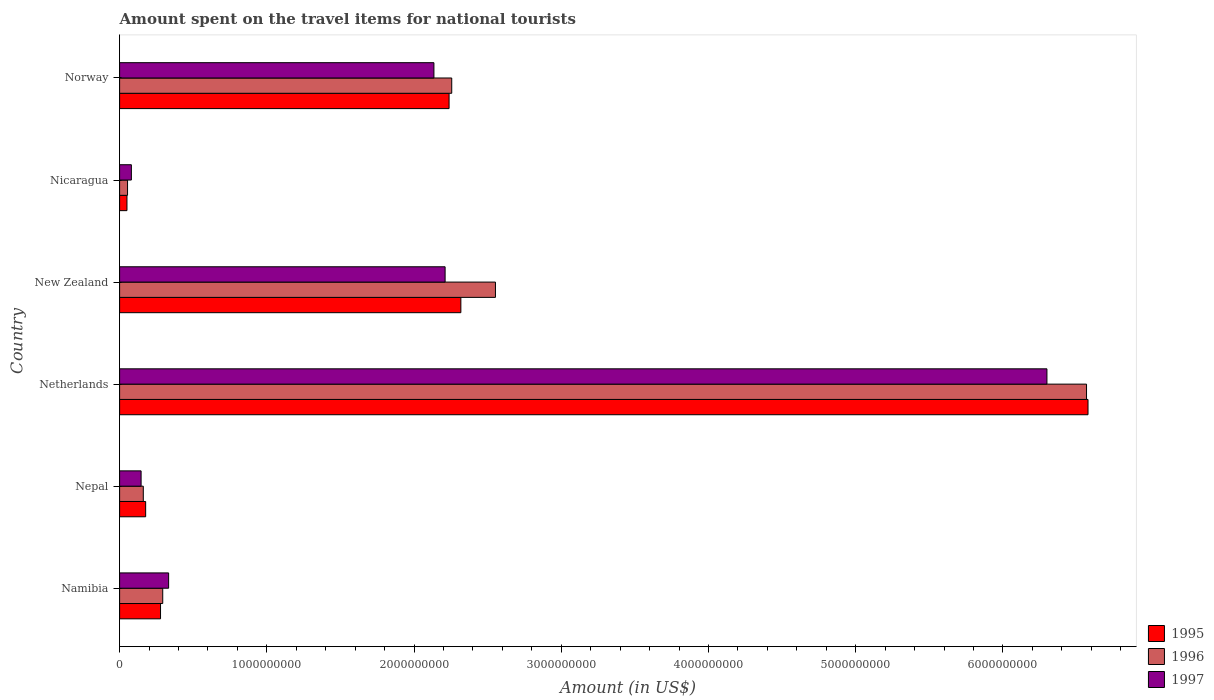How many different coloured bars are there?
Your answer should be very brief. 3. How many groups of bars are there?
Make the answer very short. 6. Are the number of bars per tick equal to the number of legend labels?
Your answer should be very brief. Yes. Are the number of bars on each tick of the Y-axis equal?
Make the answer very short. Yes. How many bars are there on the 1st tick from the top?
Ensure brevity in your answer.  3. How many bars are there on the 6th tick from the bottom?
Your answer should be very brief. 3. In how many cases, is the number of bars for a given country not equal to the number of legend labels?
Give a very brief answer. 0. What is the amount spent on the travel items for national tourists in 1996 in Nicaragua?
Keep it short and to the point. 5.40e+07. Across all countries, what is the maximum amount spent on the travel items for national tourists in 1997?
Provide a succinct answer. 6.30e+09. Across all countries, what is the minimum amount spent on the travel items for national tourists in 1995?
Provide a short and direct response. 5.00e+07. In which country was the amount spent on the travel items for national tourists in 1995 minimum?
Provide a succinct answer. Nicaragua. What is the total amount spent on the travel items for national tourists in 1997 in the graph?
Provide a succinct answer. 1.12e+1. What is the difference between the amount spent on the travel items for national tourists in 1995 in Nepal and that in Netherlands?
Your answer should be very brief. -6.40e+09. What is the difference between the amount spent on the travel items for national tourists in 1996 in New Zealand and the amount spent on the travel items for national tourists in 1997 in Norway?
Your answer should be compact. 4.18e+08. What is the average amount spent on the travel items for national tourists in 1997 per country?
Keep it short and to the point. 1.87e+09. What is the difference between the amount spent on the travel items for national tourists in 1997 and amount spent on the travel items for national tourists in 1995 in Netherlands?
Provide a short and direct response. -2.79e+08. What is the ratio of the amount spent on the travel items for national tourists in 1995 in Nepal to that in Nicaragua?
Provide a succinct answer. 3.54. What is the difference between the highest and the second highest amount spent on the travel items for national tourists in 1996?
Offer a very short reply. 4.02e+09. What is the difference between the highest and the lowest amount spent on the travel items for national tourists in 1996?
Your answer should be very brief. 6.51e+09. In how many countries, is the amount spent on the travel items for national tourists in 1997 greater than the average amount spent on the travel items for national tourists in 1997 taken over all countries?
Your answer should be compact. 3. Are all the bars in the graph horizontal?
Your response must be concise. Yes. Are the values on the major ticks of X-axis written in scientific E-notation?
Offer a very short reply. No. Does the graph contain grids?
Make the answer very short. No. How many legend labels are there?
Keep it short and to the point. 3. How are the legend labels stacked?
Ensure brevity in your answer.  Vertical. What is the title of the graph?
Offer a terse response. Amount spent on the travel items for national tourists. Does "1975" appear as one of the legend labels in the graph?
Your answer should be compact. No. What is the label or title of the X-axis?
Provide a succinct answer. Amount (in US$). What is the label or title of the Y-axis?
Offer a terse response. Country. What is the Amount (in US$) in 1995 in Namibia?
Provide a short and direct response. 2.78e+08. What is the Amount (in US$) of 1996 in Namibia?
Provide a short and direct response. 2.93e+08. What is the Amount (in US$) in 1997 in Namibia?
Offer a terse response. 3.33e+08. What is the Amount (in US$) in 1995 in Nepal?
Ensure brevity in your answer.  1.77e+08. What is the Amount (in US$) in 1996 in Nepal?
Ensure brevity in your answer.  1.61e+08. What is the Amount (in US$) in 1997 in Nepal?
Offer a very short reply. 1.46e+08. What is the Amount (in US$) of 1995 in Netherlands?
Make the answer very short. 6.58e+09. What is the Amount (in US$) of 1996 in Netherlands?
Provide a short and direct response. 6.57e+09. What is the Amount (in US$) of 1997 in Netherlands?
Give a very brief answer. 6.30e+09. What is the Amount (in US$) of 1995 in New Zealand?
Ensure brevity in your answer.  2.32e+09. What is the Amount (in US$) of 1996 in New Zealand?
Offer a terse response. 2.55e+09. What is the Amount (in US$) of 1997 in New Zealand?
Ensure brevity in your answer.  2.21e+09. What is the Amount (in US$) of 1995 in Nicaragua?
Offer a very short reply. 5.00e+07. What is the Amount (in US$) of 1996 in Nicaragua?
Provide a short and direct response. 5.40e+07. What is the Amount (in US$) in 1997 in Nicaragua?
Your response must be concise. 8.00e+07. What is the Amount (in US$) in 1995 in Norway?
Provide a succinct answer. 2.24e+09. What is the Amount (in US$) of 1996 in Norway?
Your answer should be compact. 2.26e+09. What is the Amount (in US$) in 1997 in Norway?
Offer a terse response. 2.14e+09. Across all countries, what is the maximum Amount (in US$) of 1995?
Provide a succinct answer. 6.58e+09. Across all countries, what is the maximum Amount (in US$) of 1996?
Provide a short and direct response. 6.57e+09. Across all countries, what is the maximum Amount (in US$) in 1997?
Offer a terse response. 6.30e+09. Across all countries, what is the minimum Amount (in US$) of 1995?
Your answer should be very brief. 5.00e+07. Across all countries, what is the minimum Amount (in US$) in 1996?
Offer a very short reply. 5.40e+07. Across all countries, what is the minimum Amount (in US$) in 1997?
Provide a short and direct response. 8.00e+07. What is the total Amount (in US$) in 1995 in the graph?
Ensure brevity in your answer.  1.16e+1. What is the total Amount (in US$) of 1996 in the graph?
Offer a very short reply. 1.19e+1. What is the total Amount (in US$) of 1997 in the graph?
Provide a succinct answer. 1.12e+1. What is the difference between the Amount (in US$) in 1995 in Namibia and that in Nepal?
Your response must be concise. 1.01e+08. What is the difference between the Amount (in US$) in 1996 in Namibia and that in Nepal?
Make the answer very short. 1.32e+08. What is the difference between the Amount (in US$) in 1997 in Namibia and that in Nepal?
Your answer should be very brief. 1.87e+08. What is the difference between the Amount (in US$) in 1995 in Namibia and that in Netherlands?
Provide a short and direct response. -6.30e+09. What is the difference between the Amount (in US$) of 1996 in Namibia and that in Netherlands?
Keep it short and to the point. -6.28e+09. What is the difference between the Amount (in US$) of 1997 in Namibia and that in Netherlands?
Your response must be concise. -5.97e+09. What is the difference between the Amount (in US$) in 1995 in Namibia and that in New Zealand?
Keep it short and to the point. -2.04e+09. What is the difference between the Amount (in US$) in 1996 in Namibia and that in New Zealand?
Give a very brief answer. -2.26e+09. What is the difference between the Amount (in US$) of 1997 in Namibia and that in New Zealand?
Give a very brief answer. -1.88e+09. What is the difference between the Amount (in US$) of 1995 in Namibia and that in Nicaragua?
Offer a terse response. 2.28e+08. What is the difference between the Amount (in US$) of 1996 in Namibia and that in Nicaragua?
Your answer should be very brief. 2.39e+08. What is the difference between the Amount (in US$) of 1997 in Namibia and that in Nicaragua?
Offer a very short reply. 2.53e+08. What is the difference between the Amount (in US$) of 1995 in Namibia and that in Norway?
Your answer should be very brief. -1.96e+09. What is the difference between the Amount (in US$) in 1996 in Namibia and that in Norway?
Provide a short and direct response. -1.96e+09. What is the difference between the Amount (in US$) in 1997 in Namibia and that in Norway?
Your answer should be very brief. -1.80e+09. What is the difference between the Amount (in US$) of 1995 in Nepal and that in Netherlands?
Ensure brevity in your answer.  -6.40e+09. What is the difference between the Amount (in US$) of 1996 in Nepal and that in Netherlands?
Your answer should be very brief. -6.41e+09. What is the difference between the Amount (in US$) in 1997 in Nepal and that in Netherlands?
Give a very brief answer. -6.15e+09. What is the difference between the Amount (in US$) of 1995 in Nepal and that in New Zealand?
Ensure brevity in your answer.  -2.14e+09. What is the difference between the Amount (in US$) of 1996 in Nepal and that in New Zealand?
Your response must be concise. -2.39e+09. What is the difference between the Amount (in US$) in 1997 in Nepal and that in New Zealand?
Provide a succinct answer. -2.06e+09. What is the difference between the Amount (in US$) of 1995 in Nepal and that in Nicaragua?
Offer a terse response. 1.27e+08. What is the difference between the Amount (in US$) in 1996 in Nepal and that in Nicaragua?
Offer a very short reply. 1.07e+08. What is the difference between the Amount (in US$) of 1997 in Nepal and that in Nicaragua?
Your answer should be very brief. 6.60e+07. What is the difference between the Amount (in US$) of 1995 in Nepal and that in Norway?
Your answer should be very brief. -2.06e+09. What is the difference between the Amount (in US$) in 1996 in Nepal and that in Norway?
Your answer should be very brief. -2.10e+09. What is the difference between the Amount (in US$) in 1997 in Nepal and that in Norway?
Your answer should be compact. -1.99e+09. What is the difference between the Amount (in US$) in 1995 in Netherlands and that in New Zealand?
Keep it short and to the point. 4.26e+09. What is the difference between the Amount (in US$) of 1996 in Netherlands and that in New Zealand?
Offer a terse response. 4.02e+09. What is the difference between the Amount (in US$) in 1997 in Netherlands and that in New Zealand?
Keep it short and to the point. 4.09e+09. What is the difference between the Amount (in US$) in 1995 in Netherlands and that in Nicaragua?
Offer a terse response. 6.53e+09. What is the difference between the Amount (in US$) in 1996 in Netherlands and that in Nicaragua?
Make the answer very short. 6.51e+09. What is the difference between the Amount (in US$) of 1997 in Netherlands and that in Nicaragua?
Your answer should be very brief. 6.22e+09. What is the difference between the Amount (in US$) of 1995 in Netherlands and that in Norway?
Make the answer very short. 4.34e+09. What is the difference between the Amount (in US$) of 1996 in Netherlands and that in Norway?
Make the answer very short. 4.31e+09. What is the difference between the Amount (in US$) of 1997 in Netherlands and that in Norway?
Make the answer very short. 4.16e+09. What is the difference between the Amount (in US$) of 1995 in New Zealand and that in Nicaragua?
Your answer should be compact. 2.27e+09. What is the difference between the Amount (in US$) in 1996 in New Zealand and that in Nicaragua?
Give a very brief answer. 2.50e+09. What is the difference between the Amount (in US$) in 1997 in New Zealand and that in Nicaragua?
Give a very brief answer. 2.13e+09. What is the difference between the Amount (in US$) in 1995 in New Zealand and that in Norway?
Your response must be concise. 8.00e+07. What is the difference between the Amount (in US$) in 1996 in New Zealand and that in Norway?
Your answer should be compact. 2.97e+08. What is the difference between the Amount (in US$) in 1997 in New Zealand and that in Norway?
Keep it short and to the point. 7.60e+07. What is the difference between the Amount (in US$) of 1995 in Nicaragua and that in Norway?
Keep it short and to the point. -2.19e+09. What is the difference between the Amount (in US$) of 1996 in Nicaragua and that in Norway?
Offer a terse response. -2.20e+09. What is the difference between the Amount (in US$) of 1997 in Nicaragua and that in Norway?
Your answer should be very brief. -2.06e+09. What is the difference between the Amount (in US$) of 1995 in Namibia and the Amount (in US$) of 1996 in Nepal?
Your response must be concise. 1.17e+08. What is the difference between the Amount (in US$) of 1995 in Namibia and the Amount (in US$) of 1997 in Nepal?
Offer a very short reply. 1.32e+08. What is the difference between the Amount (in US$) in 1996 in Namibia and the Amount (in US$) in 1997 in Nepal?
Keep it short and to the point. 1.47e+08. What is the difference between the Amount (in US$) in 1995 in Namibia and the Amount (in US$) in 1996 in Netherlands?
Your answer should be compact. -6.29e+09. What is the difference between the Amount (in US$) in 1995 in Namibia and the Amount (in US$) in 1997 in Netherlands?
Your answer should be very brief. -6.02e+09. What is the difference between the Amount (in US$) in 1996 in Namibia and the Amount (in US$) in 1997 in Netherlands?
Provide a short and direct response. -6.01e+09. What is the difference between the Amount (in US$) of 1995 in Namibia and the Amount (in US$) of 1996 in New Zealand?
Your response must be concise. -2.28e+09. What is the difference between the Amount (in US$) of 1995 in Namibia and the Amount (in US$) of 1997 in New Zealand?
Your answer should be compact. -1.93e+09. What is the difference between the Amount (in US$) in 1996 in Namibia and the Amount (in US$) in 1997 in New Zealand?
Your answer should be compact. -1.92e+09. What is the difference between the Amount (in US$) in 1995 in Namibia and the Amount (in US$) in 1996 in Nicaragua?
Your answer should be compact. 2.24e+08. What is the difference between the Amount (in US$) of 1995 in Namibia and the Amount (in US$) of 1997 in Nicaragua?
Provide a succinct answer. 1.98e+08. What is the difference between the Amount (in US$) in 1996 in Namibia and the Amount (in US$) in 1997 in Nicaragua?
Your response must be concise. 2.13e+08. What is the difference between the Amount (in US$) in 1995 in Namibia and the Amount (in US$) in 1996 in Norway?
Give a very brief answer. -1.98e+09. What is the difference between the Amount (in US$) of 1995 in Namibia and the Amount (in US$) of 1997 in Norway?
Your answer should be compact. -1.86e+09. What is the difference between the Amount (in US$) in 1996 in Namibia and the Amount (in US$) in 1997 in Norway?
Your response must be concise. -1.84e+09. What is the difference between the Amount (in US$) in 1995 in Nepal and the Amount (in US$) in 1996 in Netherlands?
Ensure brevity in your answer.  -6.39e+09. What is the difference between the Amount (in US$) in 1995 in Nepal and the Amount (in US$) in 1997 in Netherlands?
Your answer should be very brief. -6.12e+09. What is the difference between the Amount (in US$) in 1996 in Nepal and the Amount (in US$) in 1997 in Netherlands?
Provide a short and direct response. -6.14e+09. What is the difference between the Amount (in US$) of 1995 in Nepal and the Amount (in US$) of 1996 in New Zealand?
Your answer should be compact. -2.38e+09. What is the difference between the Amount (in US$) in 1995 in Nepal and the Amount (in US$) in 1997 in New Zealand?
Give a very brief answer. -2.03e+09. What is the difference between the Amount (in US$) of 1996 in Nepal and the Amount (in US$) of 1997 in New Zealand?
Your response must be concise. -2.05e+09. What is the difference between the Amount (in US$) of 1995 in Nepal and the Amount (in US$) of 1996 in Nicaragua?
Offer a very short reply. 1.23e+08. What is the difference between the Amount (in US$) of 1995 in Nepal and the Amount (in US$) of 1997 in Nicaragua?
Offer a very short reply. 9.70e+07. What is the difference between the Amount (in US$) in 1996 in Nepal and the Amount (in US$) in 1997 in Nicaragua?
Make the answer very short. 8.10e+07. What is the difference between the Amount (in US$) in 1995 in Nepal and the Amount (in US$) in 1996 in Norway?
Your answer should be compact. -2.08e+09. What is the difference between the Amount (in US$) of 1995 in Nepal and the Amount (in US$) of 1997 in Norway?
Provide a succinct answer. -1.96e+09. What is the difference between the Amount (in US$) of 1996 in Nepal and the Amount (in US$) of 1997 in Norway?
Your response must be concise. -1.97e+09. What is the difference between the Amount (in US$) of 1995 in Netherlands and the Amount (in US$) of 1996 in New Zealand?
Your answer should be very brief. 4.02e+09. What is the difference between the Amount (in US$) of 1995 in Netherlands and the Amount (in US$) of 1997 in New Zealand?
Make the answer very short. 4.37e+09. What is the difference between the Amount (in US$) in 1996 in Netherlands and the Amount (in US$) in 1997 in New Zealand?
Make the answer very short. 4.36e+09. What is the difference between the Amount (in US$) in 1995 in Netherlands and the Amount (in US$) in 1996 in Nicaragua?
Provide a short and direct response. 6.52e+09. What is the difference between the Amount (in US$) in 1995 in Netherlands and the Amount (in US$) in 1997 in Nicaragua?
Keep it short and to the point. 6.50e+09. What is the difference between the Amount (in US$) of 1996 in Netherlands and the Amount (in US$) of 1997 in Nicaragua?
Give a very brief answer. 6.49e+09. What is the difference between the Amount (in US$) in 1995 in Netherlands and the Amount (in US$) in 1996 in Norway?
Provide a short and direct response. 4.32e+09. What is the difference between the Amount (in US$) in 1995 in Netherlands and the Amount (in US$) in 1997 in Norway?
Ensure brevity in your answer.  4.44e+09. What is the difference between the Amount (in US$) in 1996 in Netherlands and the Amount (in US$) in 1997 in Norway?
Offer a very short reply. 4.43e+09. What is the difference between the Amount (in US$) of 1995 in New Zealand and the Amount (in US$) of 1996 in Nicaragua?
Your response must be concise. 2.26e+09. What is the difference between the Amount (in US$) of 1995 in New Zealand and the Amount (in US$) of 1997 in Nicaragua?
Offer a terse response. 2.24e+09. What is the difference between the Amount (in US$) in 1996 in New Zealand and the Amount (in US$) in 1997 in Nicaragua?
Your answer should be very brief. 2.47e+09. What is the difference between the Amount (in US$) of 1995 in New Zealand and the Amount (in US$) of 1996 in Norway?
Ensure brevity in your answer.  6.20e+07. What is the difference between the Amount (in US$) of 1995 in New Zealand and the Amount (in US$) of 1997 in Norway?
Make the answer very short. 1.83e+08. What is the difference between the Amount (in US$) of 1996 in New Zealand and the Amount (in US$) of 1997 in Norway?
Your answer should be compact. 4.18e+08. What is the difference between the Amount (in US$) in 1995 in Nicaragua and the Amount (in US$) in 1996 in Norway?
Your answer should be compact. -2.21e+09. What is the difference between the Amount (in US$) of 1995 in Nicaragua and the Amount (in US$) of 1997 in Norway?
Provide a short and direct response. -2.08e+09. What is the difference between the Amount (in US$) of 1996 in Nicaragua and the Amount (in US$) of 1997 in Norway?
Provide a short and direct response. -2.08e+09. What is the average Amount (in US$) in 1995 per country?
Keep it short and to the point. 1.94e+09. What is the average Amount (in US$) in 1996 per country?
Your answer should be compact. 1.98e+09. What is the average Amount (in US$) of 1997 per country?
Provide a short and direct response. 1.87e+09. What is the difference between the Amount (in US$) of 1995 and Amount (in US$) of 1996 in Namibia?
Make the answer very short. -1.50e+07. What is the difference between the Amount (in US$) of 1995 and Amount (in US$) of 1997 in Namibia?
Your response must be concise. -5.50e+07. What is the difference between the Amount (in US$) of 1996 and Amount (in US$) of 1997 in Namibia?
Your answer should be very brief. -4.00e+07. What is the difference between the Amount (in US$) in 1995 and Amount (in US$) in 1996 in Nepal?
Offer a terse response. 1.60e+07. What is the difference between the Amount (in US$) in 1995 and Amount (in US$) in 1997 in Nepal?
Your response must be concise. 3.10e+07. What is the difference between the Amount (in US$) of 1996 and Amount (in US$) of 1997 in Nepal?
Your response must be concise. 1.50e+07. What is the difference between the Amount (in US$) of 1995 and Amount (in US$) of 1996 in Netherlands?
Your answer should be very brief. 1.00e+07. What is the difference between the Amount (in US$) in 1995 and Amount (in US$) in 1997 in Netherlands?
Your answer should be very brief. 2.79e+08. What is the difference between the Amount (in US$) of 1996 and Amount (in US$) of 1997 in Netherlands?
Offer a terse response. 2.69e+08. What is the difference between the Amount (in US$) of 1995 and Amount (in US$) of 1996 in New Zealand?
Provide a succinct answer. -2.35e+08. What is the difference between the Amount (in US$) of 1995 and Amount (in US$) of 1997 in New Zealand?
Provide a succinct answer. 1.07e+08. What is the difference between the Amount (in US$) in 1996 and Amount (in US$) in 1997 in New Zealand?
Make the answer very short. 3.42e+08. What is the difference between the Amount (in US$) in 1995 and Amount (in US$) in 1996 in Nicaragua?
Offer a very short reply. -4.00e+06. What is the difference between the Amount (in US$) in 1995 and Amount (in US$) in 1997 in Nicaragua?
Keep it short and to the point. -3.00e+07. What is the difference between the Amount (in US$) in 1996 and Amount (in US$) in 1997 in Nicaragua?
Make the answer very short. -2.60e+07. What is the difference between the Amount (in US$) of 1995 and Amount (in US$) of 1996 in Norway?
Offer a very short reply. -1.80e+07. What is the difference between the Amount (in US$) in 1995 and Amount (in US$) in 1997 in Norway?
Ensure brevity in your answer.  1.03e+08. What is the difference between the Amount (in US$) in 1996 and Amount (in US$) in 1997 in Norway?
Your response must be concise. 1.21e+08. What is the ratio of the Amount (in US$) in 1995 in Namibia to that in Nepal?
Your answer should be very brief. 1.57. What is the ratio of the Amount (in US$) in 1996 in Namibia to that in Nepal?
Give a very brief answer. 1.82. What is the ratio of the Amount (in US$) in 1997 in Namibia to that in Nepal?
Provide a succinct answer. 2.28. What is the ratio of the Amount (in US$) of 1995 in Namibia to that in Netherlands?
Your answer should be very brief. 0.04. What is the ratio of the Amount (in US$) in 1996 in Namibia to that in Netherlands?
Your answer should be compact. 0.04. What is the ratio of the Amount (in US$) in 1997 in Namibia to that in Netherlands?
Keep it short and to the point. 0.05. What is the ratio of the Amount (in US$) in 1995 in Namibia to that in New Zealand?
Offer a very short reply. 0.12. What is the ratio of the Amount (in US$) in 1996 in Namibia to that in New Zealand?
Offer a very short reply. 0.11. What is the ratio of the Amount (in US$) in 1997 in Namibia to that in New Zealand?
Make the answer very short. 0.15. What is the ratio of the Amount (in US$) in 1995 in Namibia to that in Nicaragua?
Give a very brief answer. 5.56. What is the ratio of the Amount (in US$) of 1996 in Namibia to that in Nicaragua?
Your response must be concise. 5.43. What is the ratio of the Amount (in US$) of 1997 in Namibia to that in Nicaragua?
Offer a very short reply. 4.16. What is the ratio of the Amount (in US$) of 1995 in Namibia to that in Norway?
Offer a terse response. 0.12. What is the ratio of the Amount (in US$) of 1996 in Namibia to that in Norway?
Provide a short and direct response. 0.13. What is the ratio of the Amount (in US$) in 1997 in Namibia to that in Norway?
Offer a very short reply. 0.16. What is the ratio of the Amount (in US$) of 1995 in Nepal to that in Netherlands?
Provide a short and direct response. 0.03. What is the ratio of the Amount (in US$) of 1996 in Nepal to that in Netherlands?
Make the answer very short. 0.02. What is the ratio of the Amount (in US$) of 1997 in Nepal to that in Netherlands?
Offer a very short reply. 0.02. What is the ratio of the Amount (in US$) in 1995 in Nepal to that in New Zealand?
Your answer should be very brief. 0.08. What is the ratio of the Amount (in US$) in 1996 in Nepal to that in New Zealand?
Your answer should be very brief. 0.06. What is the ratio of the Amount (in US$) of 1997 in Nepal to that in New Zealand?
Make the answer very short. 0.07. What is the ratio of the Amount (in US$) of 1995 in Nepal to that in Nicaragua?
Provide a short and direct response. 3.54. What is the ratio of the Amount (in US$) in 1996 in Nepal to that in Nicaragua?
Keep it short and to the point. 2.98. What is the ratio of the Amount (in US$) in 1997 in Nepal to that in Nicaragua?
Ensure brevity in your answer.  1.82. What is the ratio of the Amount (in US$) in 1995 in Nepal to that in Norway?
Keep it short and to the point. 0.08. What is the ratio of the Amount (in US$) in 1996 in Nepal to that in Norway?
Give a very brief answer. 0.07. What is the ratio of the Amount (in US$) of 1997 in Nepal to that in Norway?
Your answer should be very brief. 0.07. What is the ratio of the Amount (in US$) of 1995 in Netherlands to that in New Zealand?
Offer a very short reply. 2.84. What is the ratio of the Amount (in US$) of 1996 in Netherlands to that in New Zealand?
Provide a short and direct response. 2.57. What is the ratio of the Amount (in US$) of 1997 in Netherlands to that in New Zealand?
Ensure brevity in your answer.  2.85. What is the ratio of the Amount (in US$) in 1995 in Netherlands to that in Nicaragua?
Provide a succinct answer. 131.56. What is the ratio of the Amount (in US$) of 1996 in Netherlands to that in Nicaragua?
Keep it short and to the point. 121.63. What is the ratio of the Amount (in US$) in 1997 in Netherlands to that in Nicaragua?
Make the answer very short. 78.74. What is the ratio of the Amount (in US$) in 1995 in Netherlands to that in Norway?
Your response must be concise. 2.94. What is the ratio of the Amount (in US$) in 1996 in Netherlands to that in Norway?
Keep it short and to the point. 2.91. What is the ratio of the Amount (in US$) in 1997 in Netherlands to that in Norway?
Your answer should be very brief. 2.95. What is the ratio of the Amount (in US$) of 1995 in New Zealand to that in Nicaragua?
Offer a very short reply. 46.36. What is the ratio of the Amount (in US$) of 1996 in New Zealand to that in Nicaragua?
Your answer should be very brief. 47.28. What is the ratio of the Amount (in US$) of 1997 in New Zealand to that in Nicaragua?
Offer a very short reply. 27.64. What is the ratio of the Amount (in US$) of 1995 in New Zealand to that in Norway?
Ensure brevity in your answer.  1.04. What is the ratio of the Amount (in US$) of 1996 in New Zealand to that in Norway?
Your answer should be compact. 1.13. What is the ratio of the Amount (in US$) in 1997 in New Zealand to that in Norway?
Make the answer very short. 1.04. What is the ratio of the Amount (in US$) of 1995 in Nicaragua to that in Norway?
Keep it short and to the point. 0.02. What is the ratio of the Amount (in US$) of 1996 in Nicaragua to that in Norway?
Offer a very short reply. 0.02. What is the ratio of the Amount (in US$) in 1997 in Nicaragua to that in Norway?
Keep it short and to the point. 0.04. What is the difference between the highest and the second highest Amount (in US$) of 1995?
Provide a succinct answer. 4.26e+09. What is the difference between the highest and the second highest Amount (in US$) of 1996?
Your response must be concise. 4.02e+09. What is the difference between the highest and the second highest Amount (in US$) in 1997?
Make the answer very short. 4.09e+09. What is the difference between the highest and the lowest Amount (in US$) of 1995?
Ensure brevity in your answer.  6.53e+09. What is the difference between the highest and the lowest Amount (in US$) of 1996?
Your answer should be compact. 6.51e+09. What is the difference between the highest and the lowest Amount (in US$) in 1997?
Make the answer very short. 6.22e+09. 